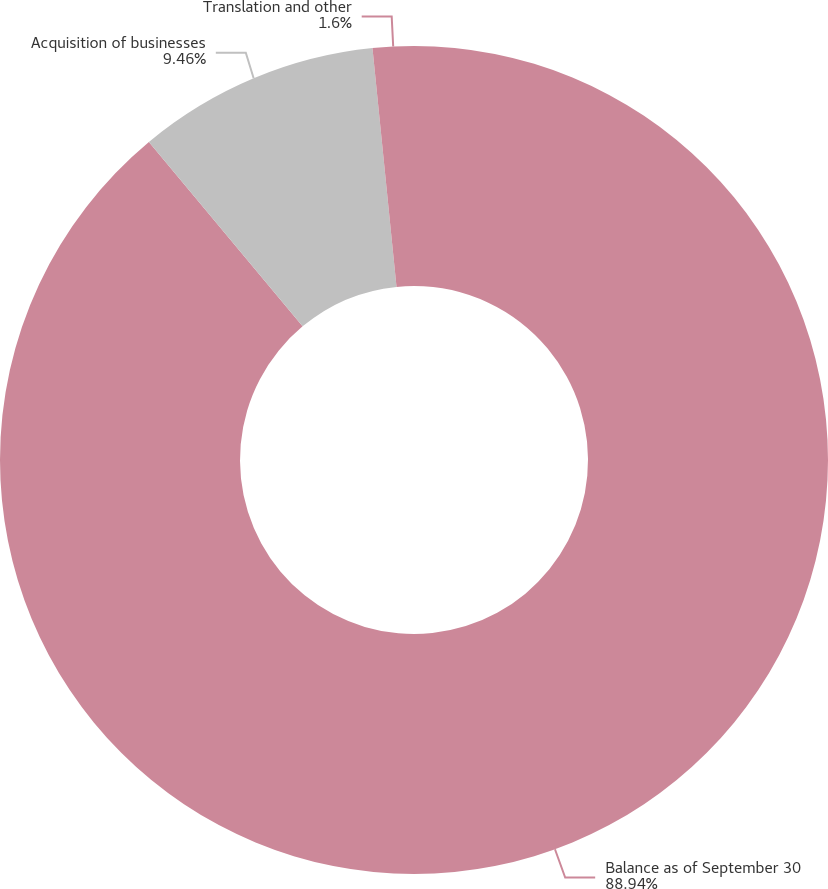Convert chart to OTSL. <chart><loc_0><loc_0><loc_500><loc_500><pie_chart><fcel>Balance as of September 30<fcel>Acquisition of businesses<fcel>Translation and other<nl><fcel>88.94%<fcel>9.46%<fcel>1.6%<nl></chart> 